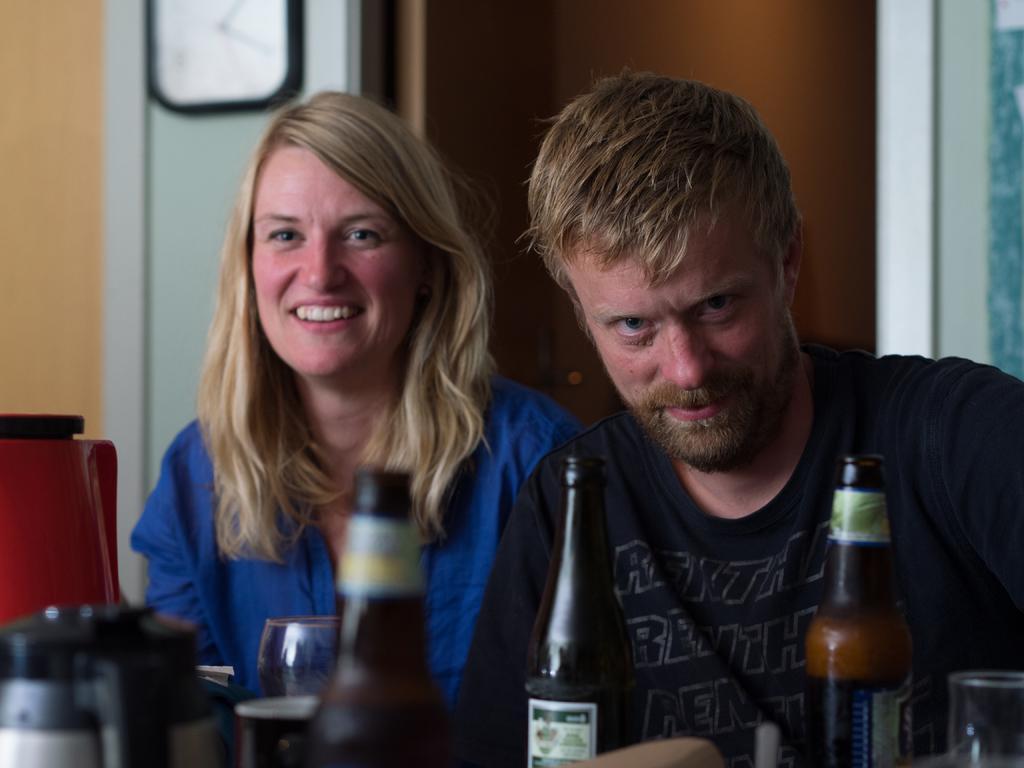Please provide a concise description of this image. As we can see in the image there is are two persons standing over here and there are bottles in the front. 